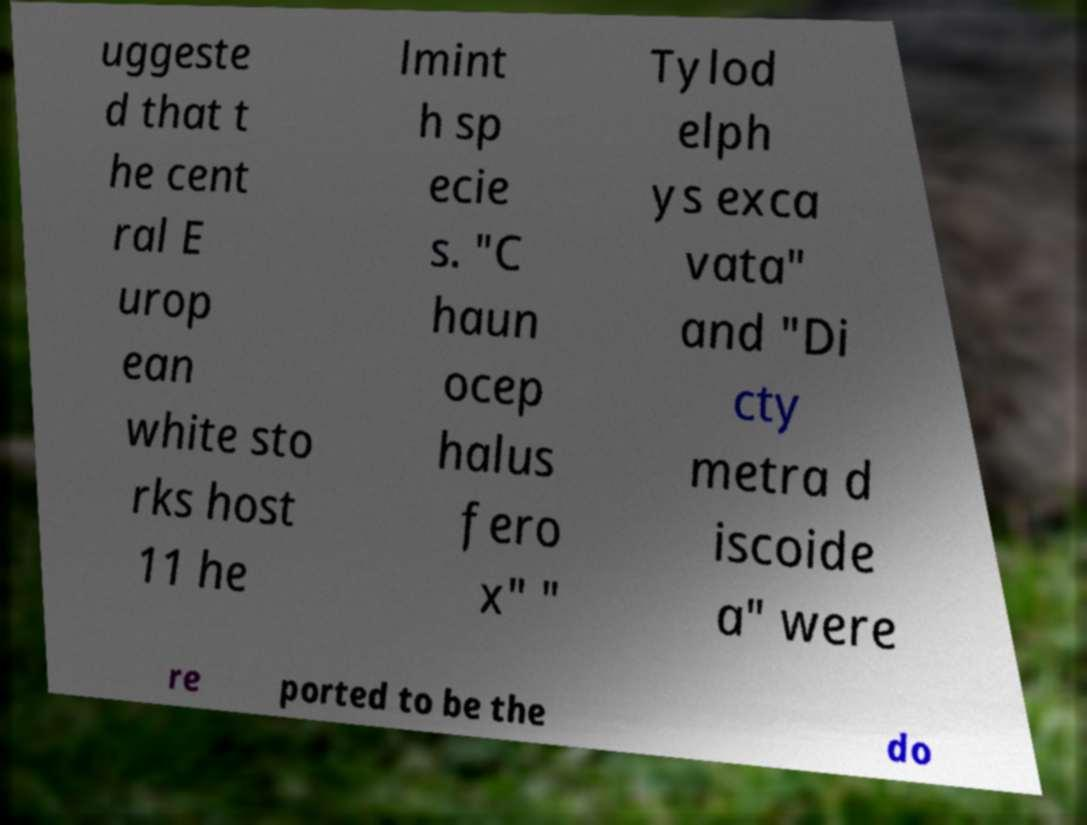What messages or text are displayed in this image? I need them in a readable, typed format. uggeste d that t he cent ral E urop ean white sto rks host 11 he lmint h sp ecie s. "C haun ocep halus fero x" " Tylod elph ys exca vata" and "Di cty metra d iscoide a" were re ported to be the do 